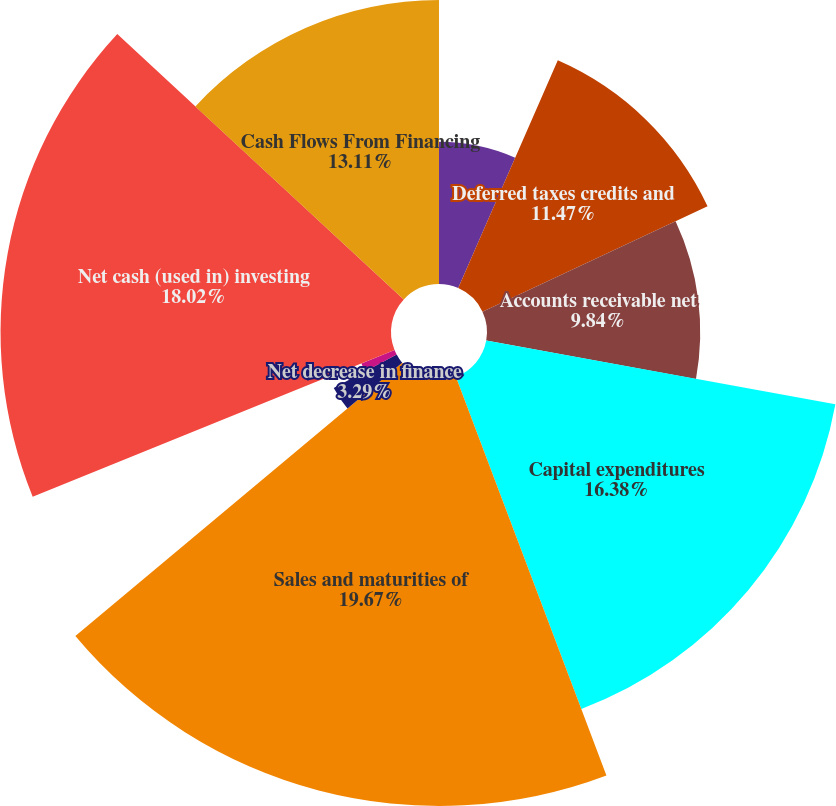<chart> <loc_0><loc_0><loc_500><loc_500><pie_chart><fcel>Postretirement benefits<fcel>Deferred taxes credits and<fcel>Accounts receivable net<fcel>Capital expenditures<fcel>Sales and maturities of<fcel>Net decrease in finance<fcel>Cash received (paid) for<fcel>Other investing activities<fcel>Net cash (used in) investing<fcel>Cash Flows From Financing<nl><fcel>6.56%<fcel>11.47%<fcel>9.84%<fcel>16.38%<fcel>19.66%<fcel>3.29%<fcel>1.65%<fcel>0.01%<fcel>18.02%<fcel>13.11%<nl></chart> 